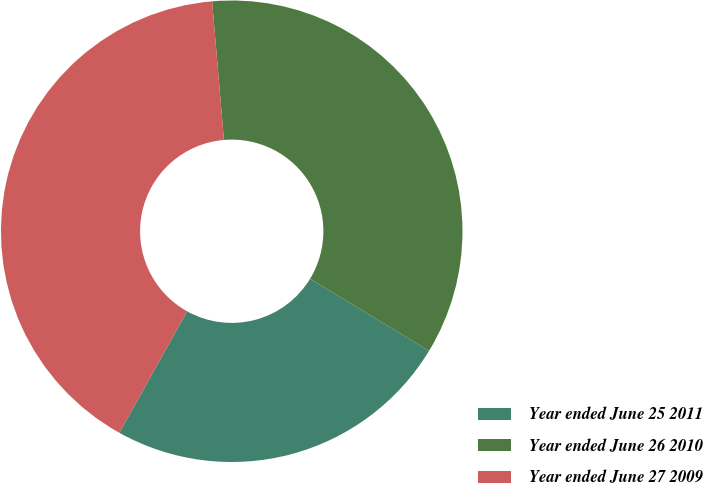<chart> <loc_0><loc_0><loc_500><loc_500><pie_chart><fcel>Year ended June 25 2011<fcel>Year ended June 26 2010<fcel>Year ended June 27 2009<nl><fcel>24.42%<fcel>35.03%<fcel>40.55%<nl></chart> 